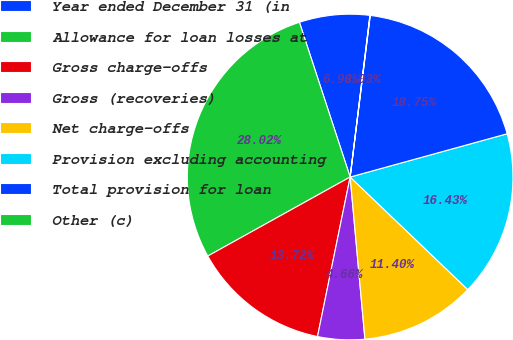Convert chart to OTSL. <chart><loc_0><loc_0><loc_500><loc_500><pie_chart><fcel>Year ended December 31 (in<fcel>Allowance for loan losses at<fcel>Gross charge-offs<fcel>Gross (recoveries)<fcel>Net charge-offs<fcel>Provision excluding accounting<fcel>Total provision for loan<fcel>Other (c)<nl><fcel>6.98%<fcel>28.02%<fcel>13.72%<fcel>4.66%<fcel>11.4%<fcel>16.43%<fcel>18.75%<fcel>0.03%<nl></chart> 